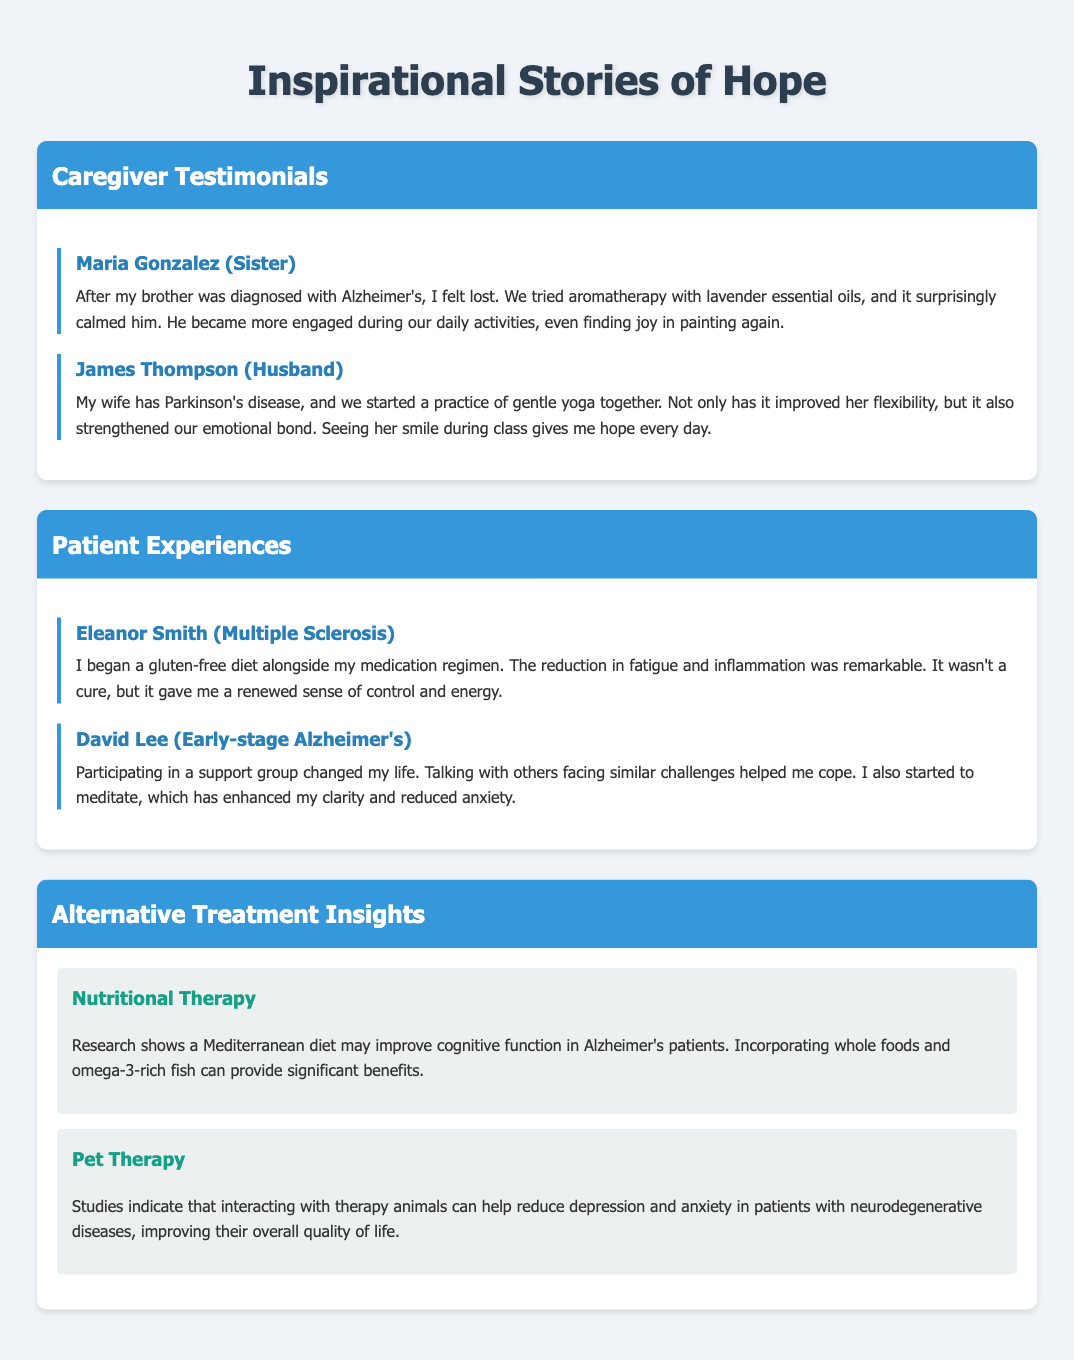what is the title of the document? The title is displayed at the top of the document in an emphasized format.
Answer: Inspirational Stories of Hope who is the caregiver mentioned in the first testimonial? The name of the caregiver is highlighted at the beginning of the testimonial section.
Answer: Maria Gonzalez what condition does David Lee have? The condition is specified in the title of the patient's experience section.
Answer: Early-stage Alzheimer's which therapy improved Eleanor Smith's fatigue and inflammation? The type of dietary approach is clearly stated in her testimonial.
Answer: Gluten-free diet what type of diet may improve cognitive function in Alzheimer's patients? This information is found in the insights about alternative treatments in the document.
Answer: Mediterranean diet how does James Thompson describe the effect of yoga on his relationship with his wife? The emotional impact of yoga on their bond is a central theme of the caregiver’s testimonial.
Answer: Strengthened emotional bond what therapy is associated with reducing depression and anxiety? The type of therapy is mentioned in the alternative treatment insights.
Answer: Pet Therapy how many caregiver testimonials are included in the document? The number of testimonials is straightforwardly presented in the caregiver section.
Answer: Two what was the main benefit of participating in a support group for David Lee? The benefit is outlined in the description of his experiences in the document.
Answer: Helped me cope 